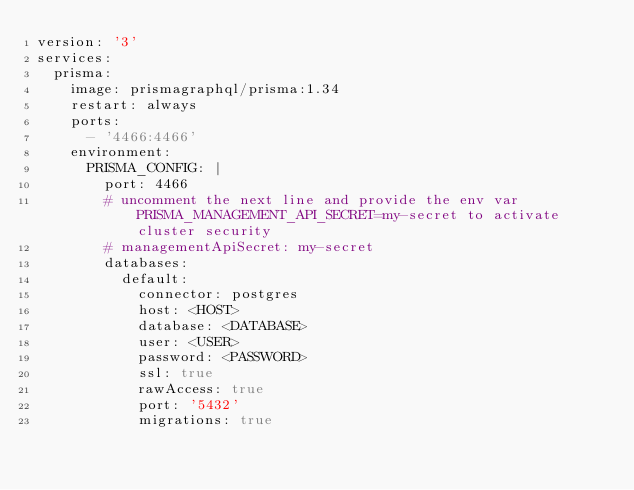<code> <loc_0><loc_0><loc_500><loc_500><_YAML_>version: '3'
services:
  prisma:
    image: prismagraphql/prisma:1.34
    restart: always
    ports:
      - '4466:4466'
    environment:
      PRISMA_CONFIG: |
        port: 4466
        # uncomment the next line and provide the env var PRISMA_MANAGEMENT_API_SECRET=my-secret to activate cluster security
        # managementApiSecret: my-secret
        databases:
          default:
            connector: postgres
            host: <HOST>
            database: <DATABASE>
            user: <USER>
            password: <PASSWORD>
            ssl: true
            rawAccess: true
            port: '5432'
            migrations: true
</code> 